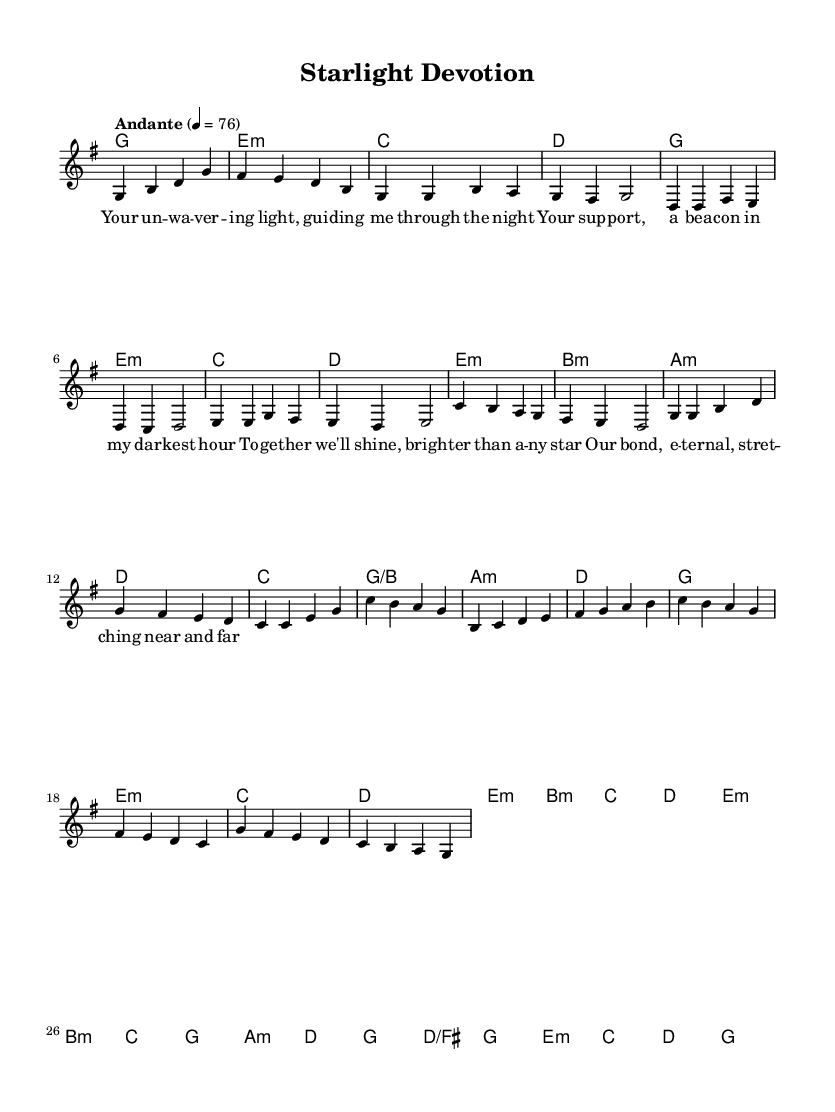What is the key signature of this music? The key signature is G major, which contains one sharp (F#), as indicated at the beginning of the sheet music.
Answer: G major What is the time signature of this music? The time signature is 4/4, meaning there are four beats in each measure, as shown in the beginning portion of the sheet music.
Answer: 4/4 What is the tempo marking of this piece? The tempo marking is "Andante," which indicates a moderately slow tempo. The exact speed is given as 4 = 76, meaning there should be 76 beats per minute.
Answer: Andante How many measures are in the chorus section? In the chorus section, there are 8 measures as it comprises two phrases, each containing four measures.
Answer: 8 What is the first chord of the bridge? The first chord of the bridge is E minor, which is the first chord indicated in the harmony section corresponding to the bridge.
Answer: E minor How does the lyrical theme reflect K-Pop fandom? The lyrics express deep devotion and support, which is a common theme in K-Pop ballads, emphasizing the emotional connection between fans and their idols.
Answer: Devotion and support 